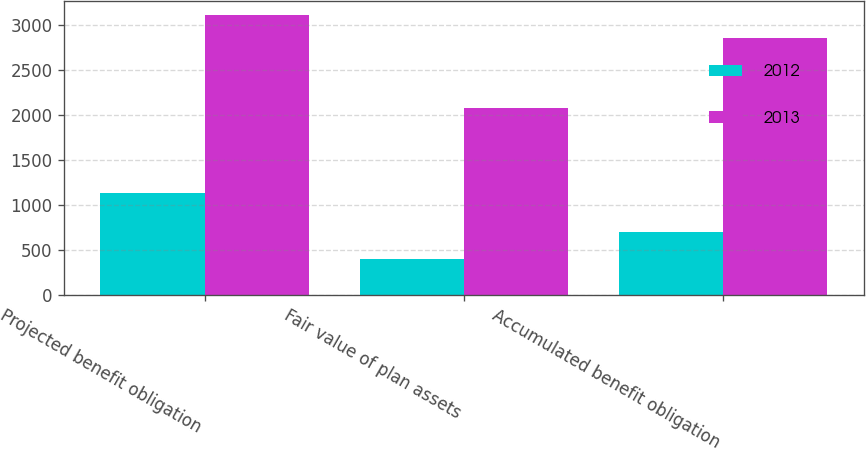<chart> <loc_0><loc_0><loc_500><loc_500><stacked_bar_chart><ecel><fcel>Projected benefit obligation<fcel>Fair value of plan assets<fcel>Accumulated benefit obligation<nl><fcel>2012<fcel>1130<fcel>402<fcel>700<nl><fcel>2013<fcel>3112<fcel>2080<fcel>2855<nl></chart> 